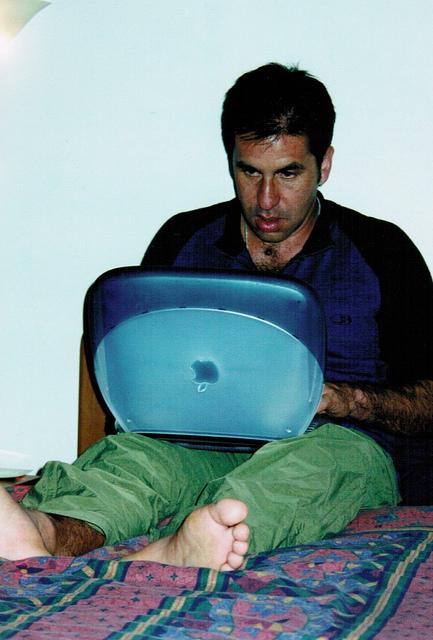What font is used in Apple logo? Please explain your reasoning. helvetica. This helvectica is used as the font for apple. 